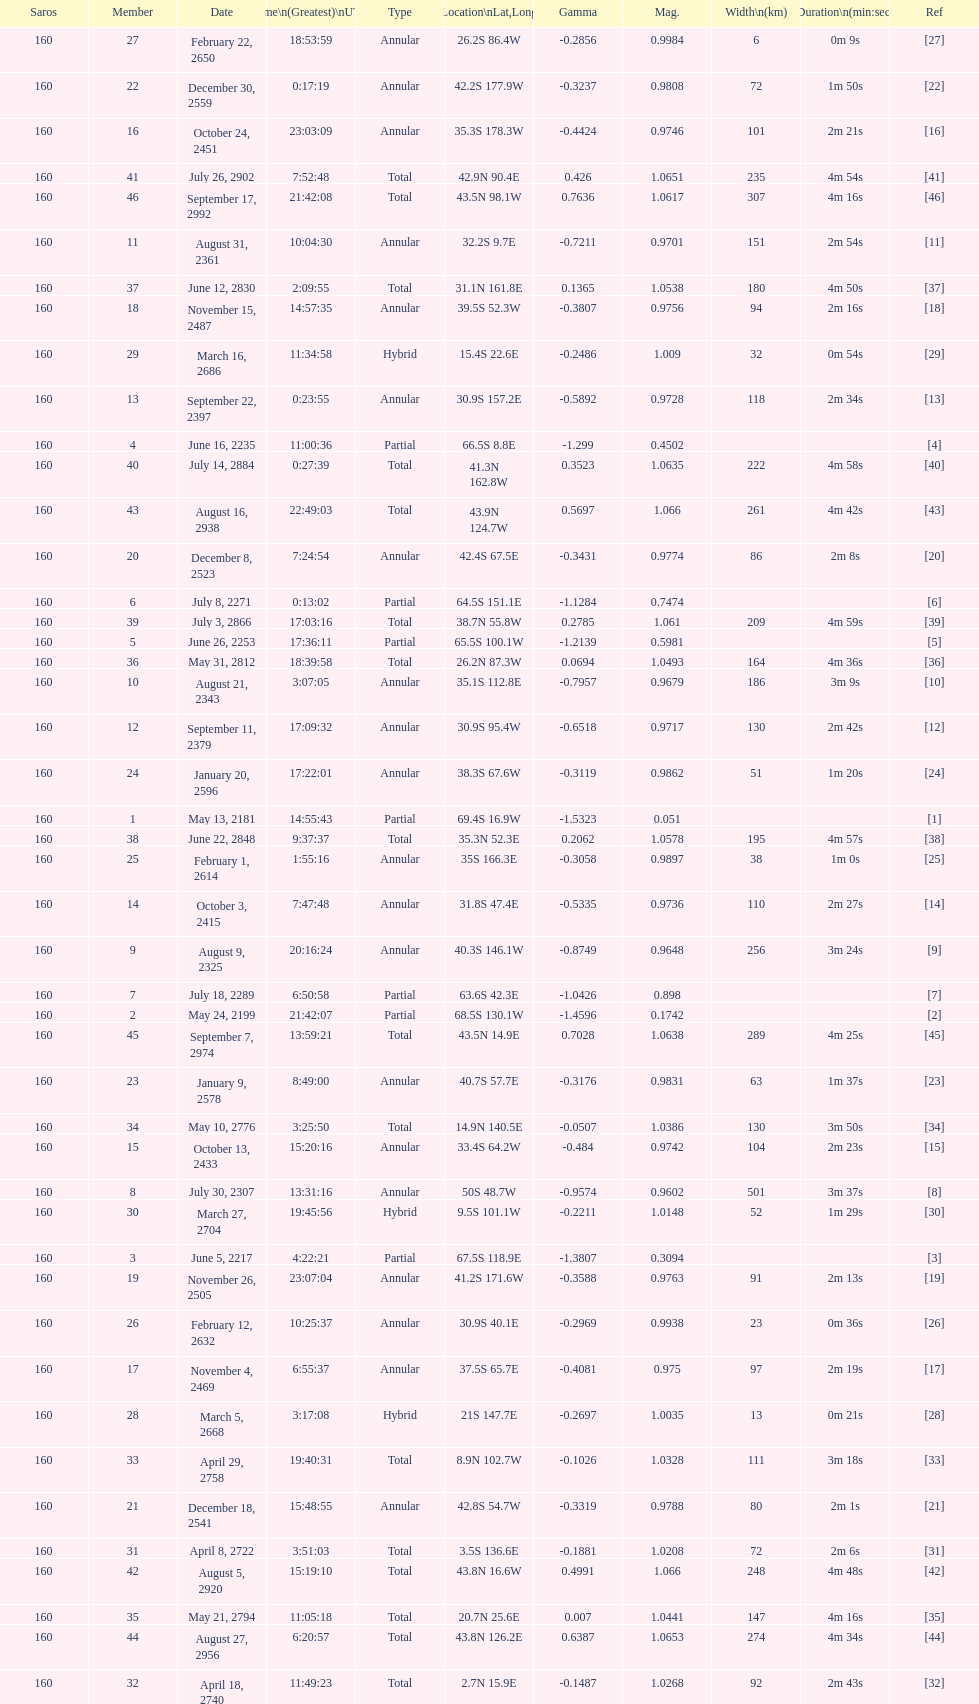Name one that has the same latitude as member number 12. 13. 